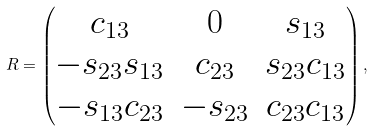Convert formula to latex. <formula><loc_0><loc_0><loc_500><loc_500>R = \begin{pmatrix} c _ { 1 3 } & 0 & s _ { 1 3 } \\ - s _ { 2 3 } s _ { 1 3 } & c _ { 2 3 } & s _ { 2 3 } c _ { 1 3 } \\ - s _ { 1 3 } c _ { 2 3 } & - s _ { 2 3 } & c _ { 2 3 } c _ { 1 3 } \end{pmatrix} ,</formula> 